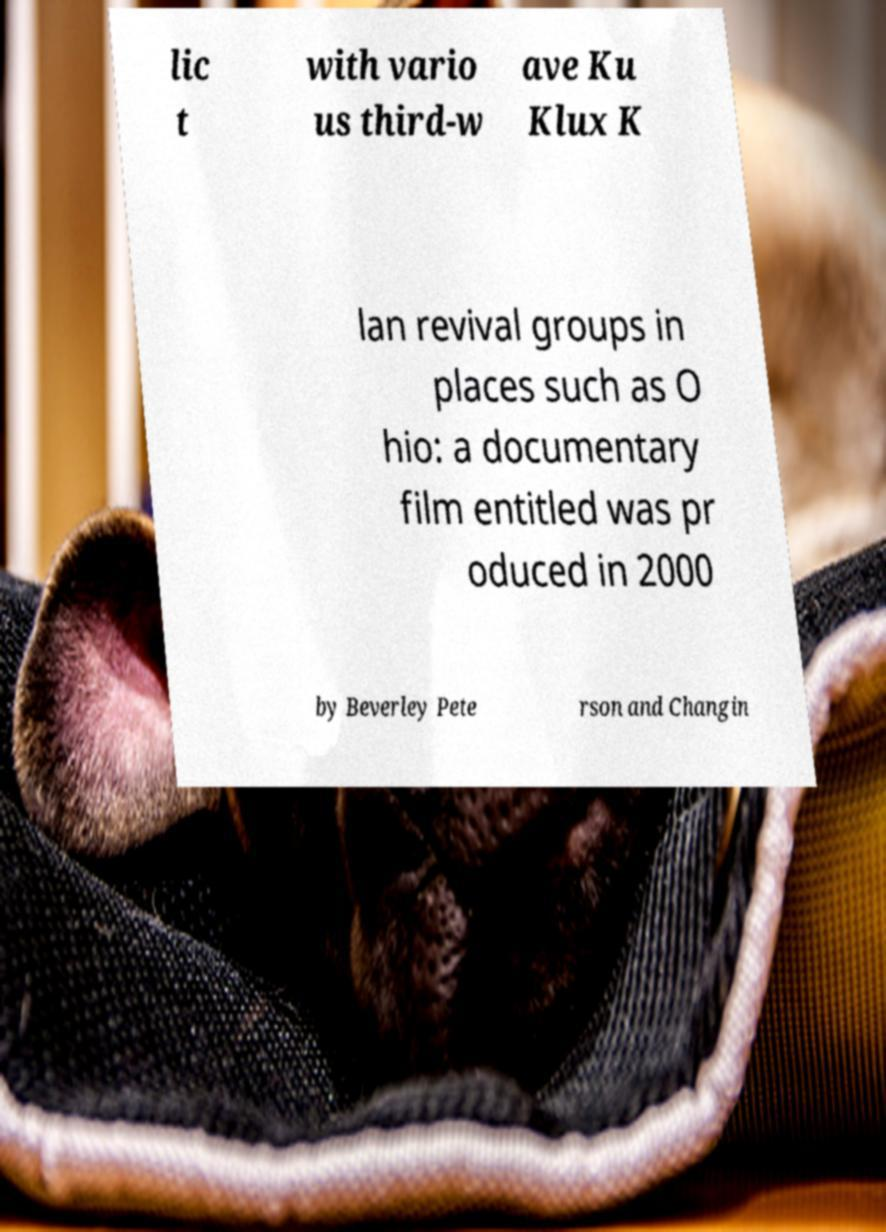Could you extract and type out the text from this image? lic t with vario us third-w ave Ku Klux K lan revival groups in places such as O hio: a documentary film entitled was pr oduced in 2000 by Beverley Pete rson and Changin 